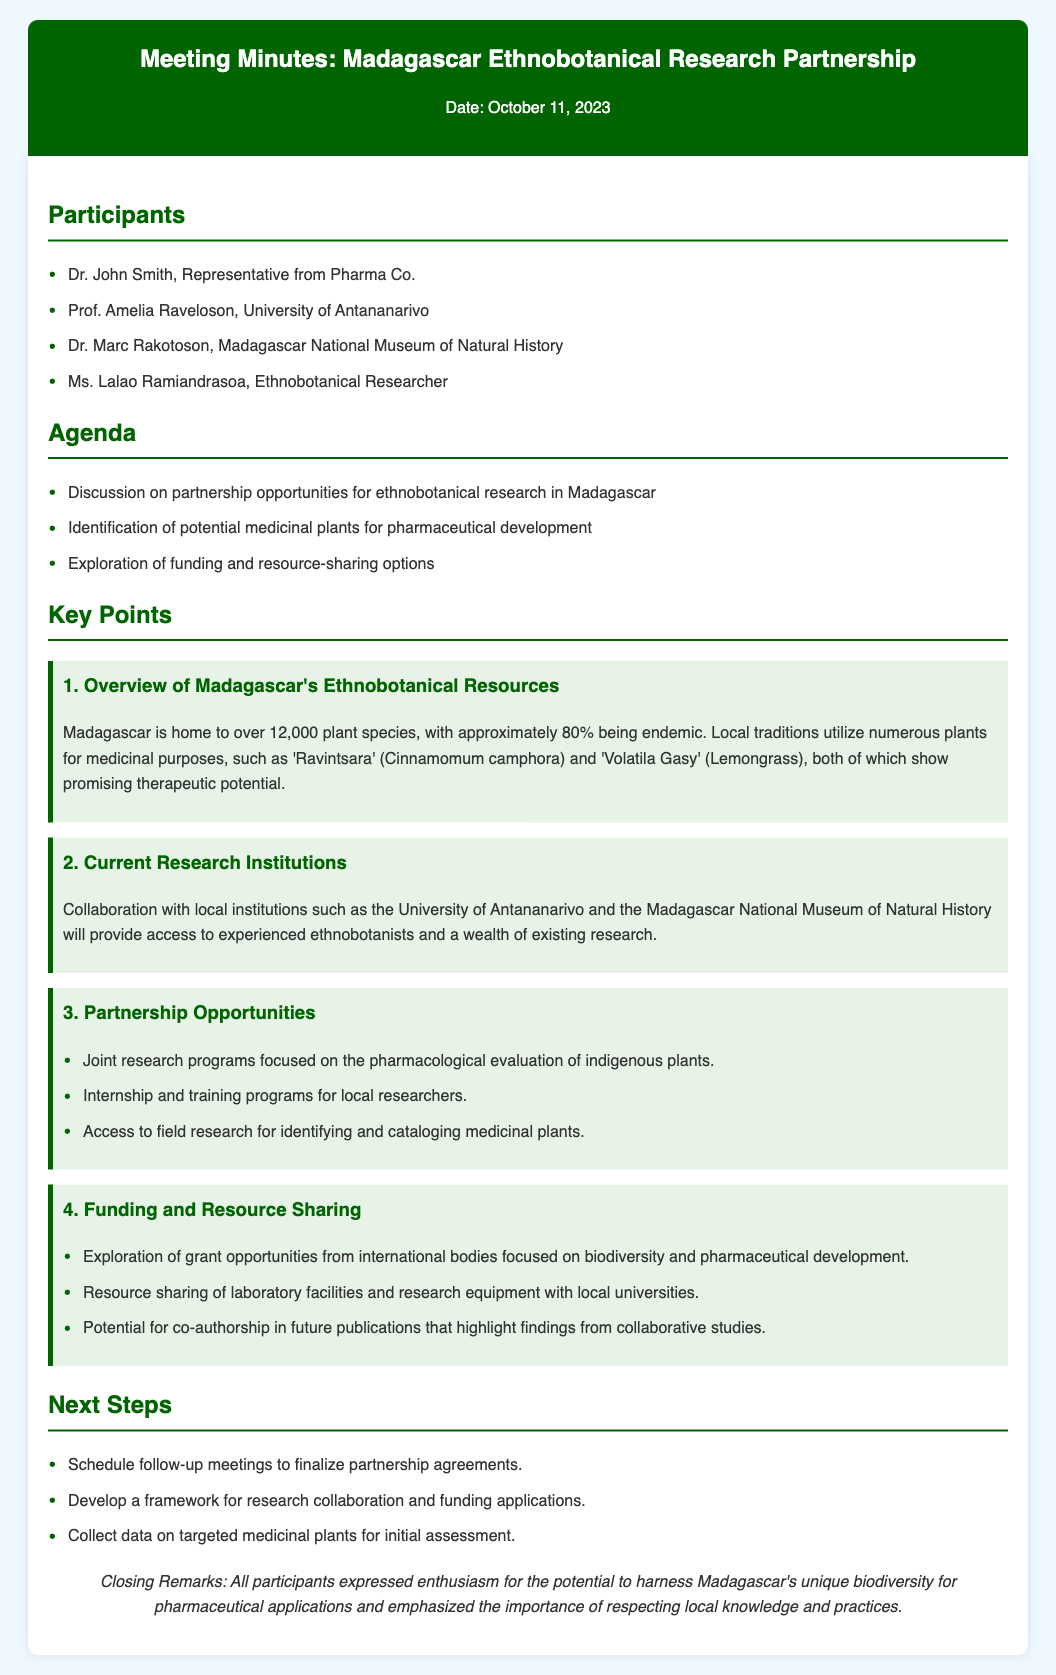What is the date of the meeting? The date of the meeting is mentioned in the header of the document.
Answer: October 11, 2023 Who is the representative from Pharma Co.? The document lists the participants, including the representative from Pharma Co.
Answer: Dr. John Smith What percentage of Madagascar's plant species is endemic? The document provides specific information about the endemism of plant species in Madagascar.
Answer: 80% What is one of the medicinal plants mentioned in the overview? The key points section includes examples of plants used for medicinal purposes.
Answer: Ravintsara Which institution is located in Antananarivo? The document specifies which research institution is in Antananarivo.
Answer: University of Antananarivo What is one partnership opportunity discussed? The document lists several partnership opportunities under a specific key point.
Answer: Joint research programs How many steps are listed in the next steps section? By counting the items under the next steps section, we can determine the number of steps.
Answer: 3 What emphasis was made in the closing remarks? The closing remarks highlight a key sentiment expressed by the participants.
Answer: Respecting local knowledge and practices 